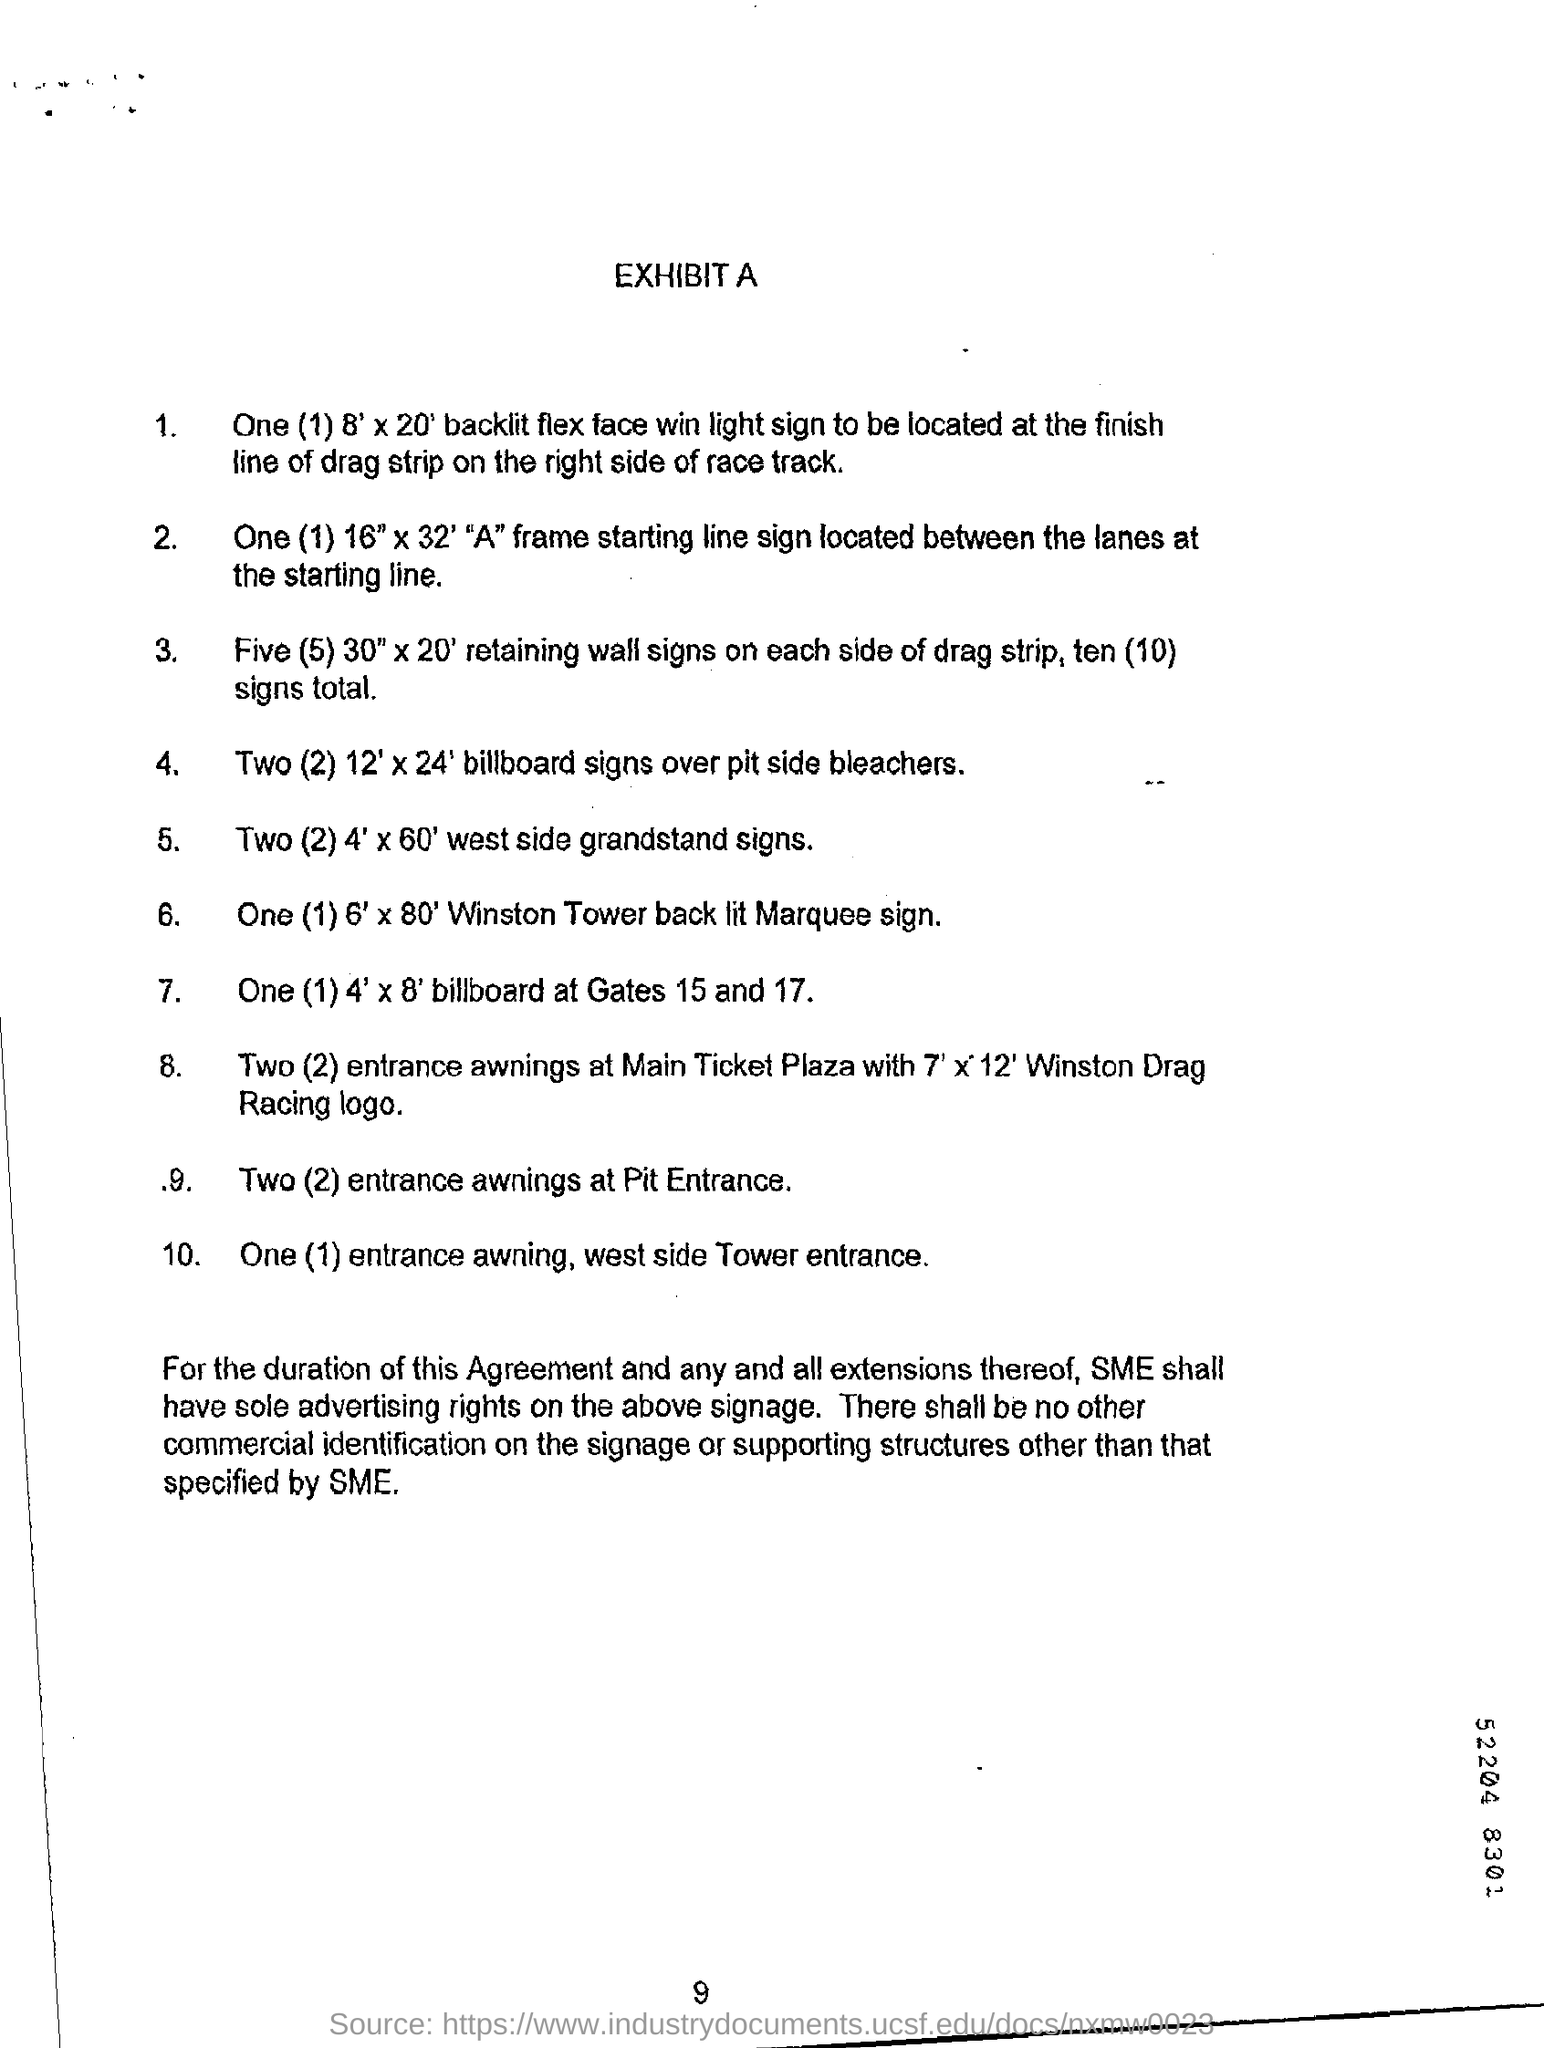List a handful of essential elements in this visual. The heading at the top of the page is Exhibit A. The bottom number on the page is 9. 